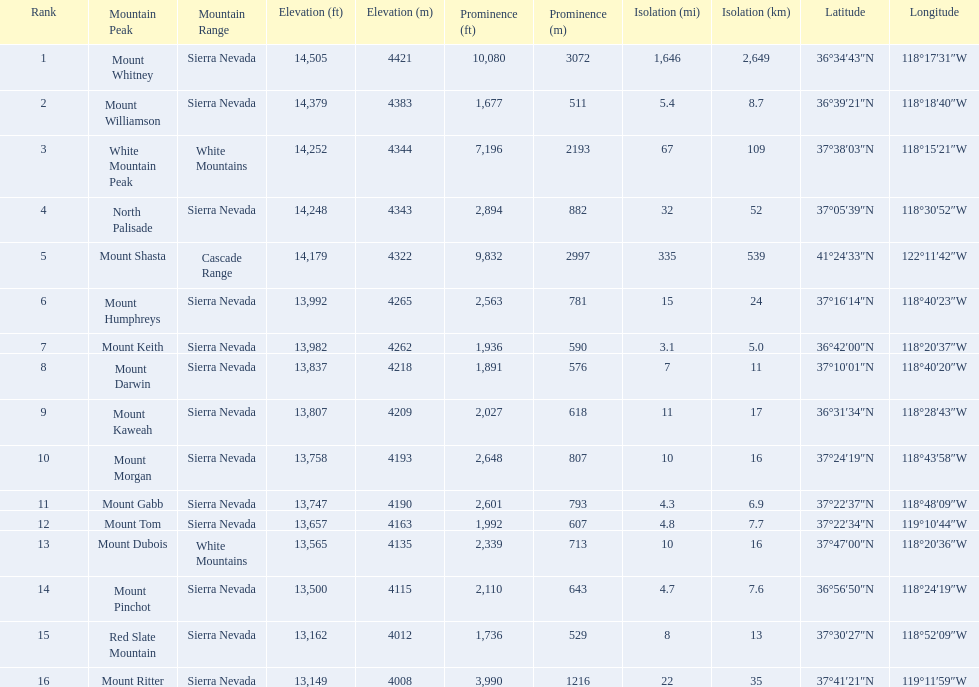Which are the highest mountain peaks in california? Mount Whitney, Mount Williamson, White Mountain Peak, North Palisade, Mount Shasta, Mount Humphreys, Mount Keith, Mount Darwin, Mount Kaweah, Mount Morgan, Mount Gabb, Mount Tom, Mount Dubois, Mount Pinchot, Red Slate Mountain, Mount Ritter. Of those, which are not in the sierra nevada range? White Mountain Peak, Mount Shasta, Mount Dubois. Of the mountains not in the sierra nevada range, which is the only mountain in the cascades? Mount Shasta. 